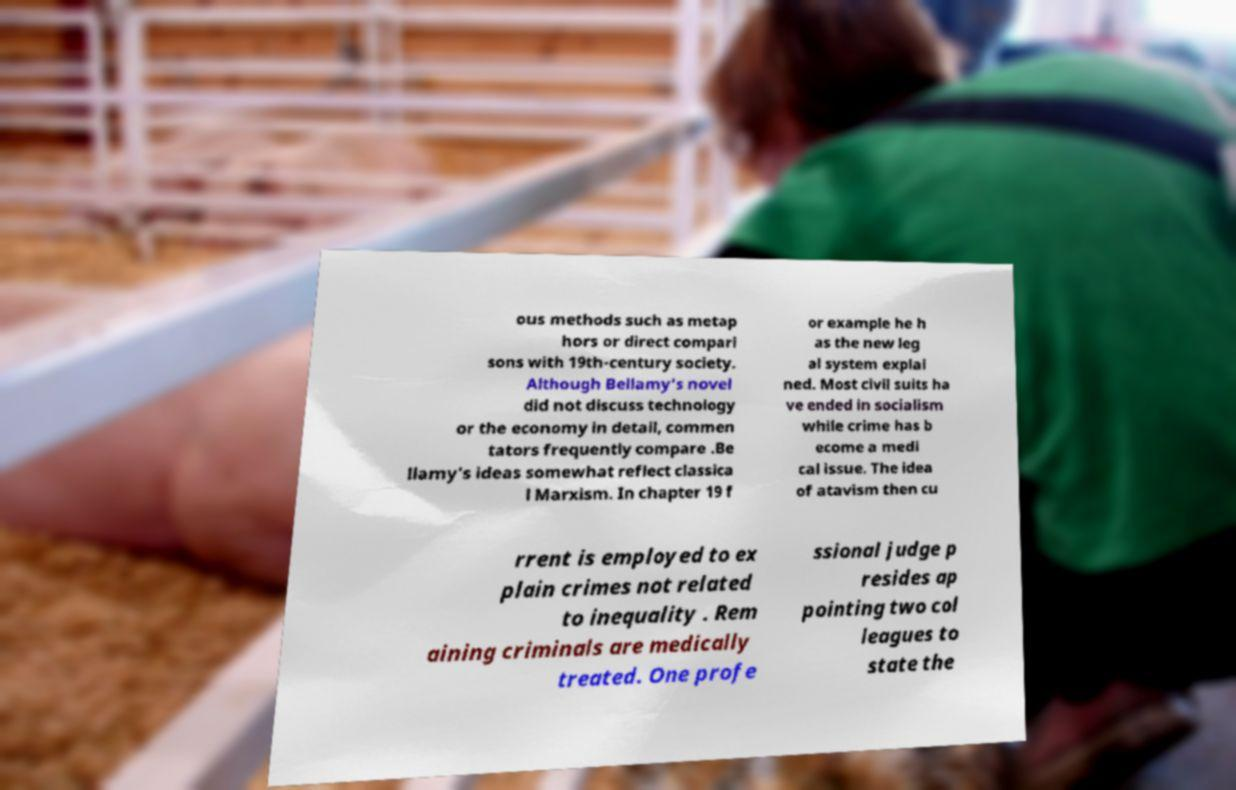I need the written content from this picture converted into text. Can you do that? ous methods such as metap hors or direct compari sons with 19th-century society. Although Bellamy's novel did not discuss technology or the economy in detail, commen tators frequently compare .Be llamy's ideas somewhat reflect classica l Marxism. In chapter 19 f or example he h as the new leg al system explai ned. Most civil suits ha ve ended in socialism while crime has b ecome a medi cal issue. The idea of atavism then cu rrent is employed to ex plain crimes not related to inequality . Rem aining criminals are medically treated. One profe ssional judge p resides ap pointing two col leagues to state the 